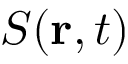Convert formula to latex. <formula><loc_0><loc_0><loc_500><loc_500>S ( r , t )</formula> 